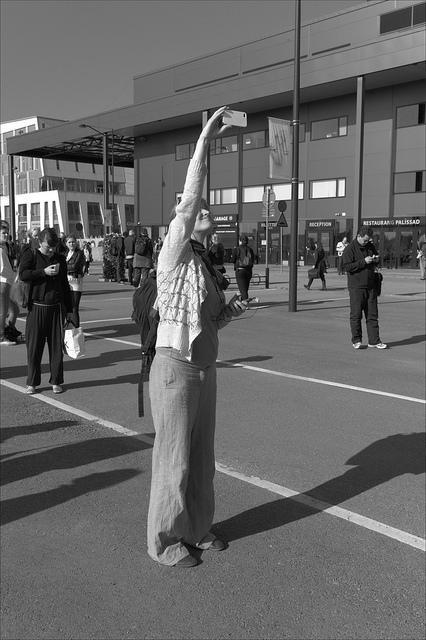How many people can you see?
Give a very brief answer. 4. 